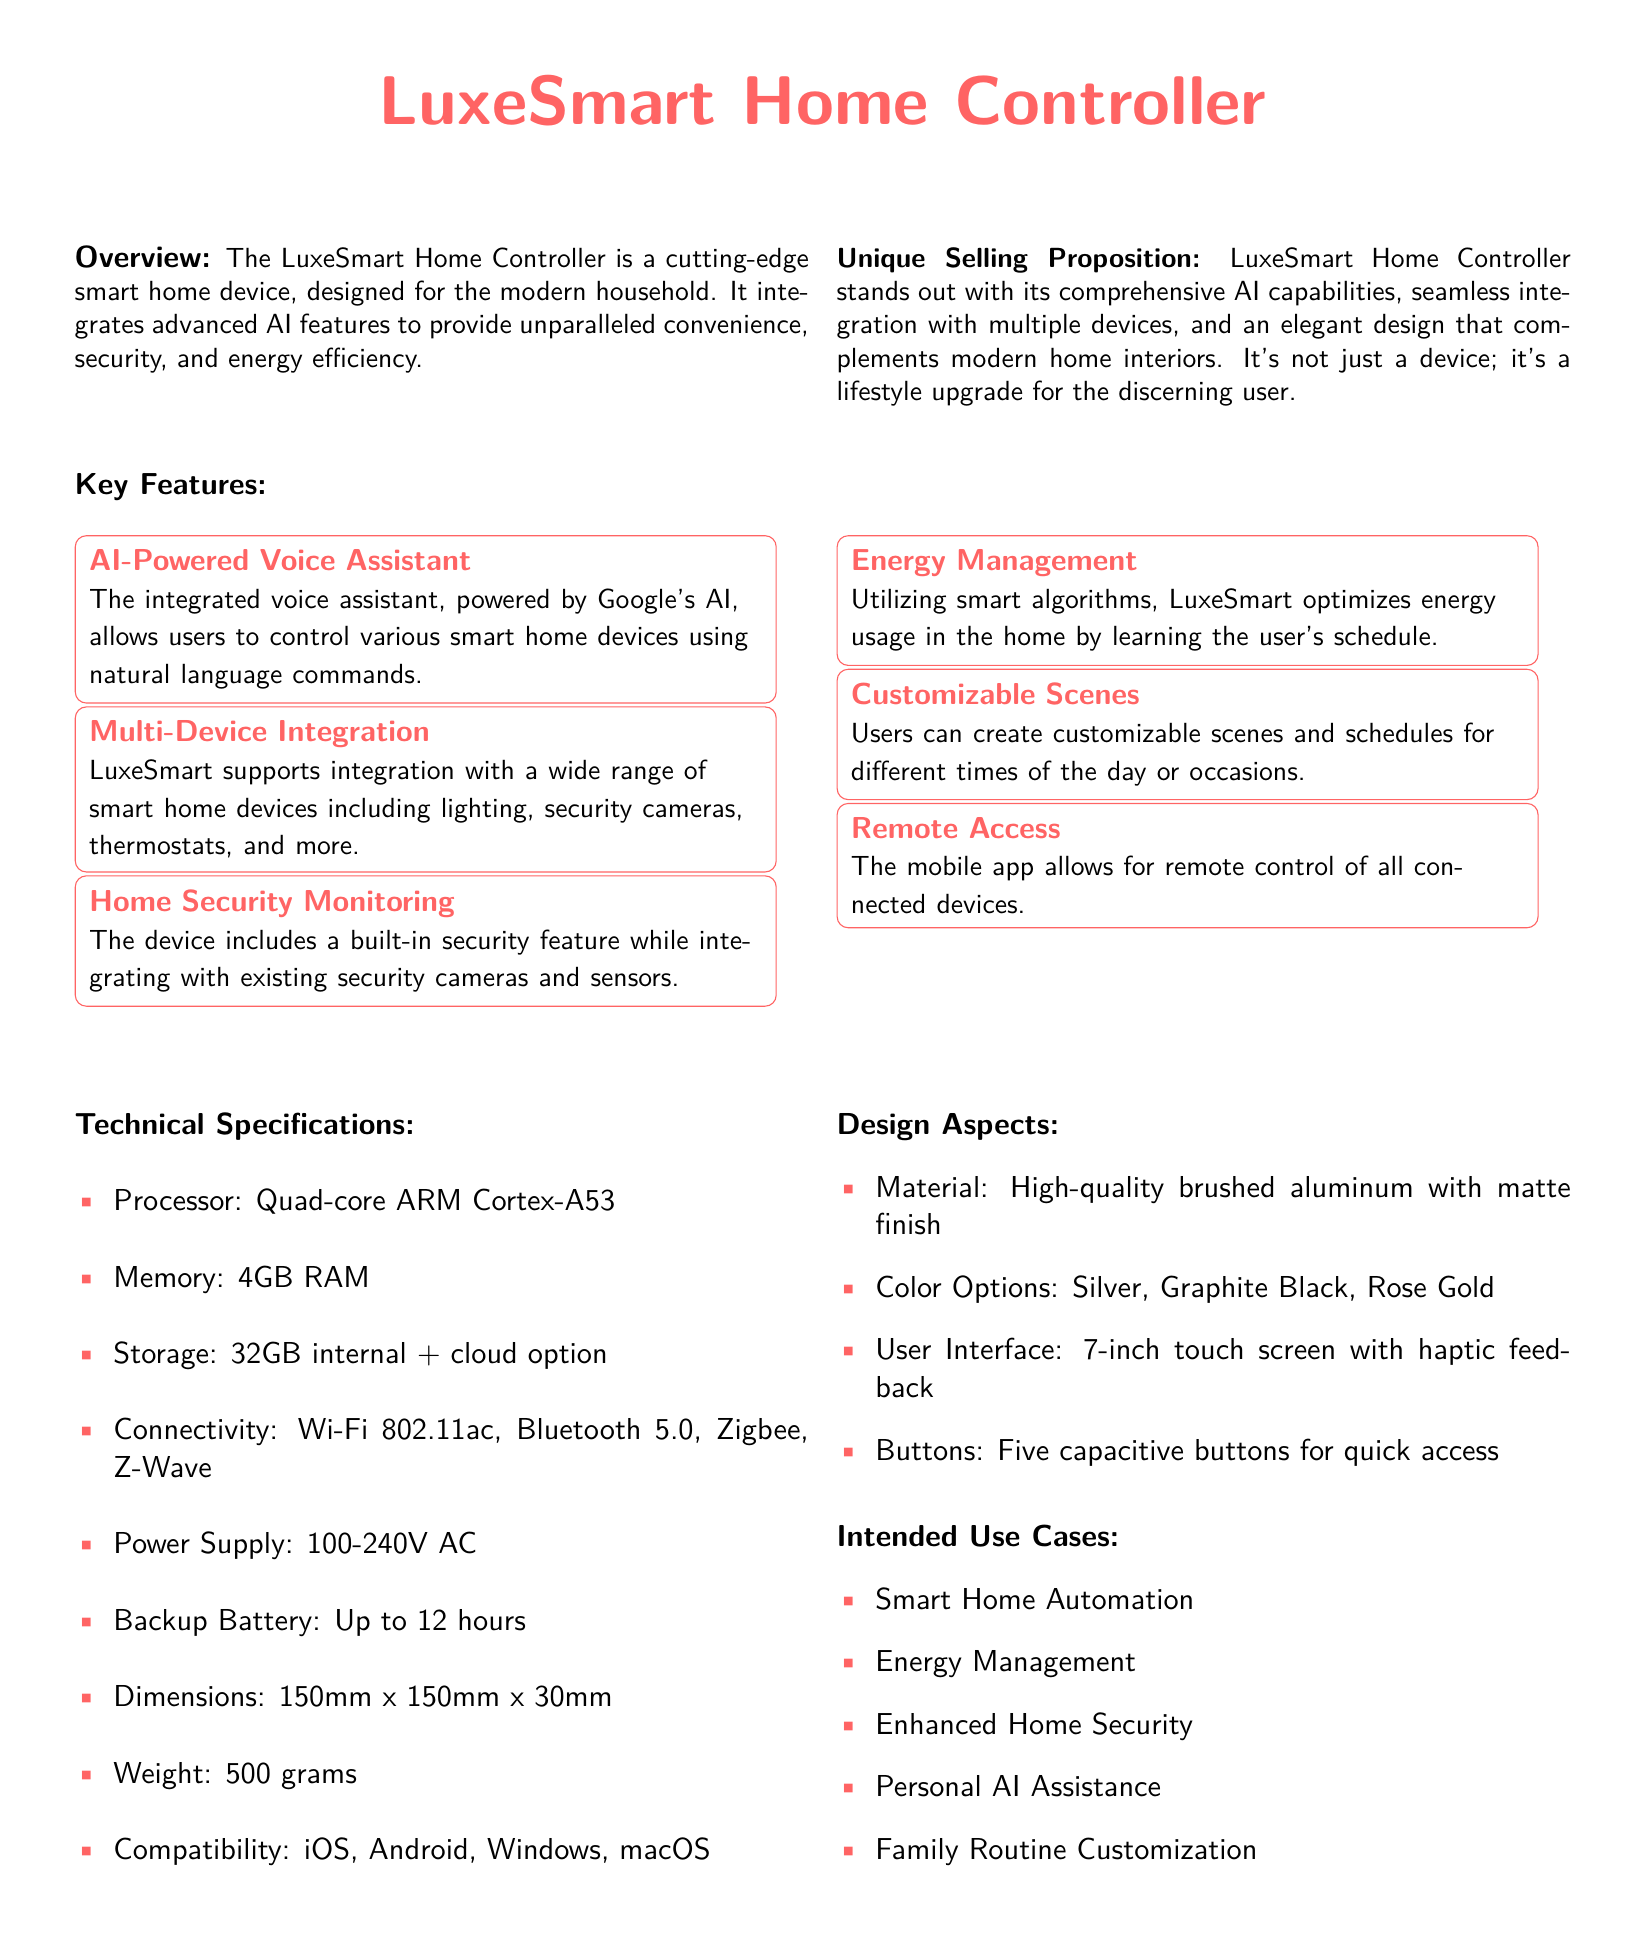What is the product name? The product name is stated prominently at the top of the document.
Answer: LuxeSmart Home Controller What kind of processor does it have? The technical specifications list the processor type.
Answer: Quad-core ARM Cortex-A53 How much RAM is included? The amount of RAM is specified under technical specifications.
Answer: 4GB RAM What materials are used in its design? The design aspects section describes the materials used.
Answer: High-quality brushed aluminum What are the available color options? The document lists the color options available for the product.
Answer: Silver, Graphite Black, Rose Gold What feature allows remote control of devices? The key features section mentions the ability for remote control through a specific feature.
Answer: Mobile app What is a unique selling proposition of the product? The unique selling proposition is described in the overview section.
Answer: Comprehensive AI capabilities What is the backup battery life? The technical specifications state the backup battery duration.
Answer: Up to 12 hours What is one intended use case mentioned in the document? The intended use cases section lists different applications for the product.
Answer: Smart Home Automation 